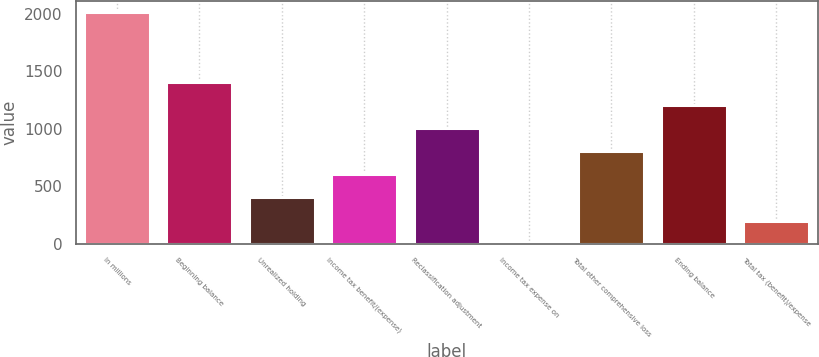Convert chart to OTSL. <chart><loc_0><loc_0><loc_500><loc_500><bar_chart><fcel>In millions<fcel>Beginning balance<fcel>Unrealized holding<fcel>Income tax benefit/(expense)<fcel>Reclassification adjustment<fcel>Income tax expense on<fcel>Total other comprehensive loss<fcel>Ending balance<fcel>Total tax (benefit)/expense<nl><fcel>2014<fcel>1409.86<fcel>402.96<fcel>604.34<fcel>1007.1<fcel>0.2<fcel>805.72<fcel>1208.48<fcel>201.58<nl></chart> 